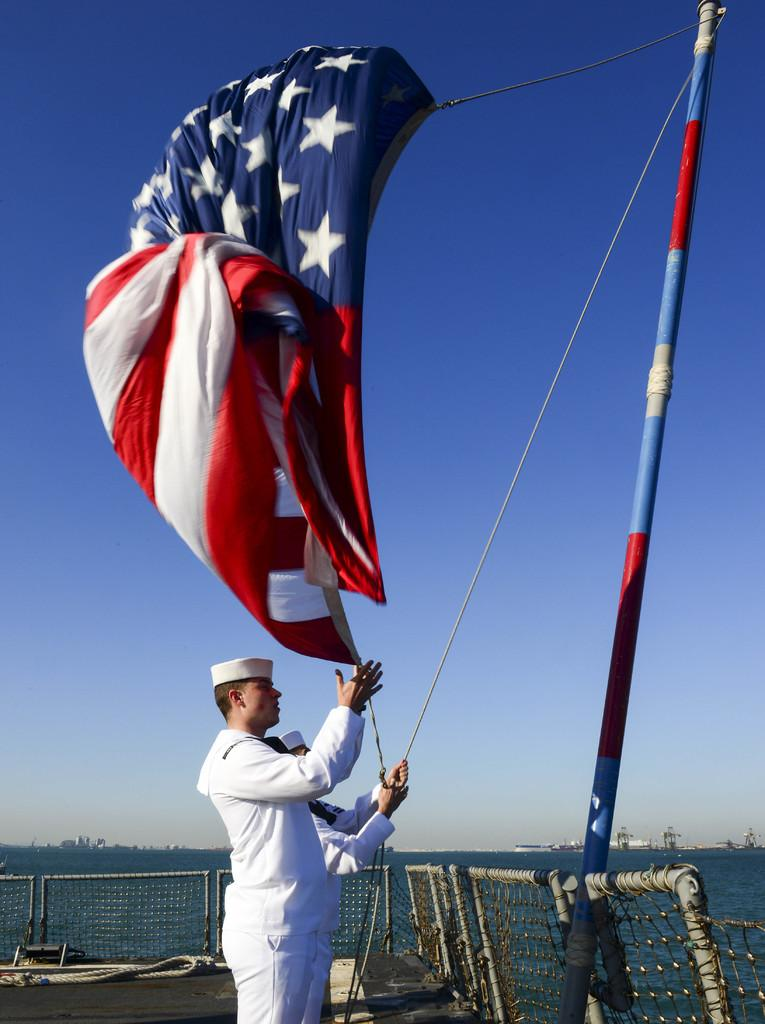How many people are in the image? There are two persons in the image. What are the people wearing on their heads? Both persons are wearing caps. What is one person holding in the image? One person is holding a rope. What is the person holding the rope doing? The person is hoisting a flag on a pole. What can be seen in the background of the image? There is fencing, water, and the sky visible in the background of the image. What type of berry can be seen growing on the fencing in the image? There are no berries visible in the image, and the fencing is not described as having any plants or vegetation growing on it. 